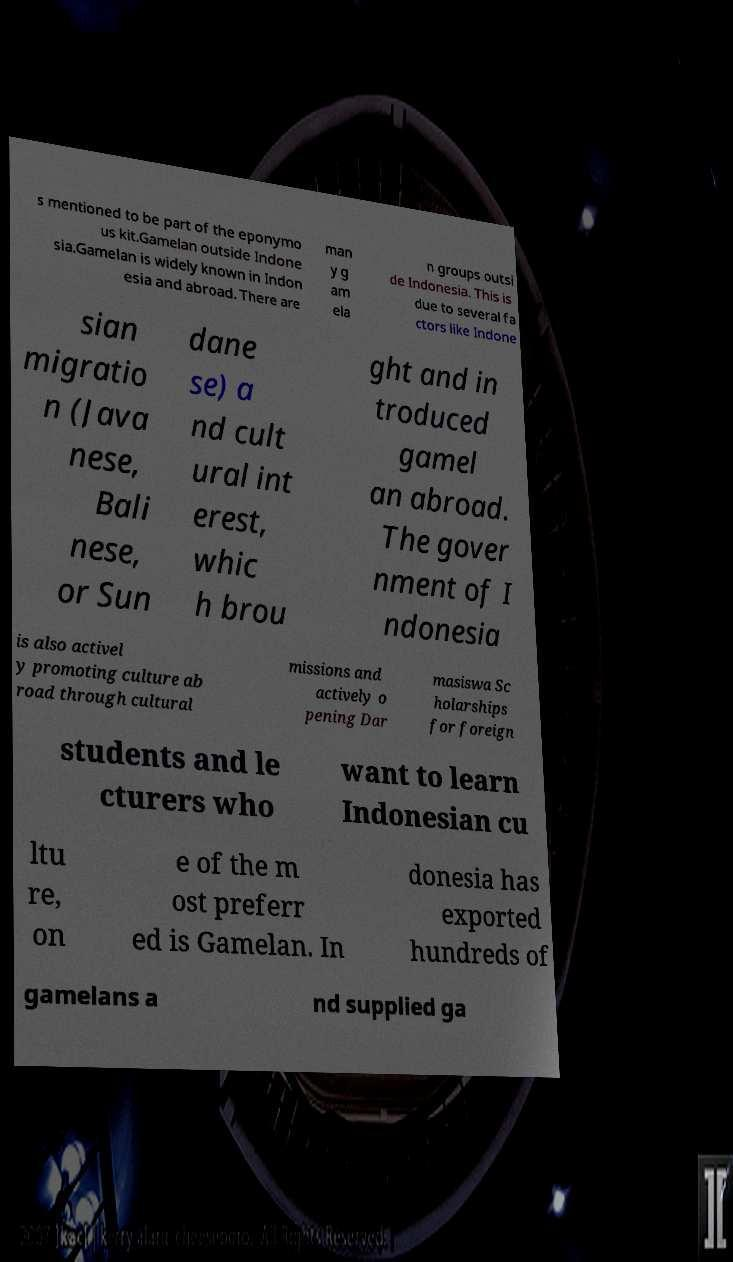Can you accurately transcribe the text from the provided image for me? s mentioned to be part of the eponymo us kit.Gamelan outside Indone sia.Gamelan is widely known in Indon esia and abroad. There are man y g am ela n groups outsi de Indonesia. This is due to several fa ctors like Indone sian migratio n (Java nese, Bali nese, or Sun dane se) a nd cult ural int erest, whic h brou ght and in troduced gamel an abroad. The gover nment of I ndonesia is also activel y promoting culture ab road through cultural missions and actively o pening Dar masiswa Sc holarships for foreign students and le cturers who want to learn Indonesian cu ltu re, on e of the m ost preferr ed is Gamelan. In donesia has exported hundreds of gamelans a nd supplied ga 